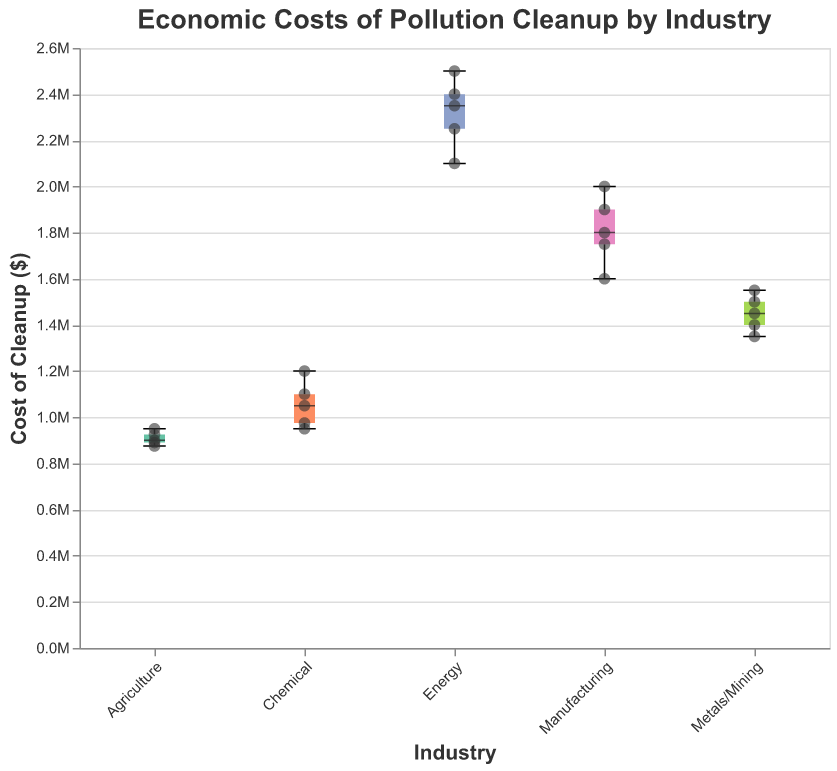Which industry has the highest median cost of cleanup? The boxplot shows the median value with a bold line within each box. The Energy industry has the highest median cost of cleanup indicated by the highest bold line.
Answer: Energy What is the cost of cleanup for ExxonMobil? The scatter points represent individual data points. By looking at the scatter point for ExxonMobil under the Energy category, we can see it is at $2,500,000.
Answer: $2,500,000 Which industry has the widest range of cleanup costs? The range is defined by the distance from the minimum to the maximum value in a boxplot. The Manufacturing industry has the widest range of cleanup costs, indicated by the largest gap between the minimum and maximum values.
Answer: Manufacturing How does the median cleanup cost of the Chemical industry compare to that of the Metals/Mining industry? The median value is indicated by the bold line within each box. The Chemical industry has a higher median than the Metals/Mining industry.
Answer: Chemical is higher What is the average cost of cleanup for companies in the Agriculture industry? The data points for the Agriculture industry are $875,000, $925,000, $950,000, $900,000, and $890,000. Sum these values and divide by the number of data points: (875,000 + 925,000 + 950,000 + 900,000 + 890,000) / 5 = 908,000.
Answer: $908,000 Which company has the lowest cleanup cost in the energy sector? By examining the individual scatter points for the Energy sector, the lowest cost is associated with NextEra Energy, which has a cleanup cost of $2,100,000.
Answer: NextEra Energy Which industry shows the least variability in cleanup costs? Variability can be visually assessed by the width of the interquartile ranges and the length of the whiskers. The Agriculture industry appears to have the least variability due to the narrow box and short whiskers.
Answer: Agriculture Among Manufacturing, Energy, and Metals/Mining, which industry has the highest maximum cleanup cost? The highest points of the whiskers indicate the maximum values. The Energy industry has the highest maximum cleanup cost, represented by a scatter point of $2,500,000 for ExxonMobil.
Answer: Energy What is the difference between the maximum and minimum cleanup costs for the Chemical industry? The maximum value for the Chemical industry is $1,200,000 (DuPont), and the minimum is $950,000 (Dow Chemical). The difference is $1,200,000 - $950,000 = $250,000.
Answer: $250,000 